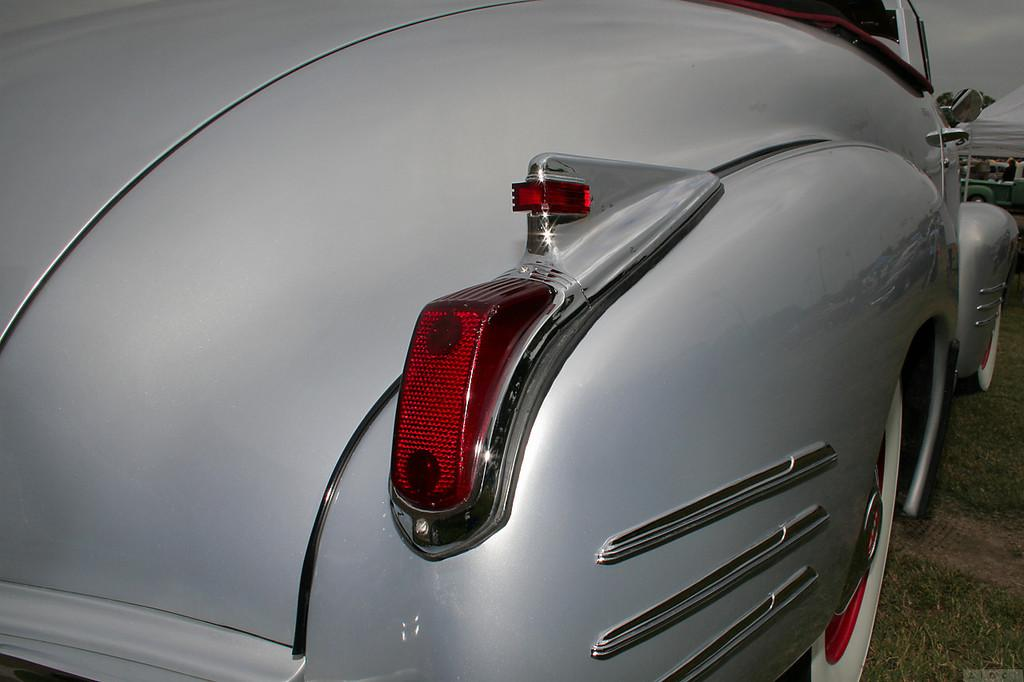What is the main subject of the image? There is a vehicle in the image. Can you describe the color of the vehicle? The vehicle is ash-colored. Where is the vehicle located in the image? The vehicle is on the ground. What color tint can be seen on the right side of the image? There is a white color tint on the right side of the image. What is visible in the background of the image? The sky is white in the background of the image. Can you tell me how many snails are crawling on the vehicle in the image? There are no snails present in the image; it only features a vehicle on the ground. What type of journey is the vehicle taking in the image? The image does not provide any information about the vehicle's journey or destination. 